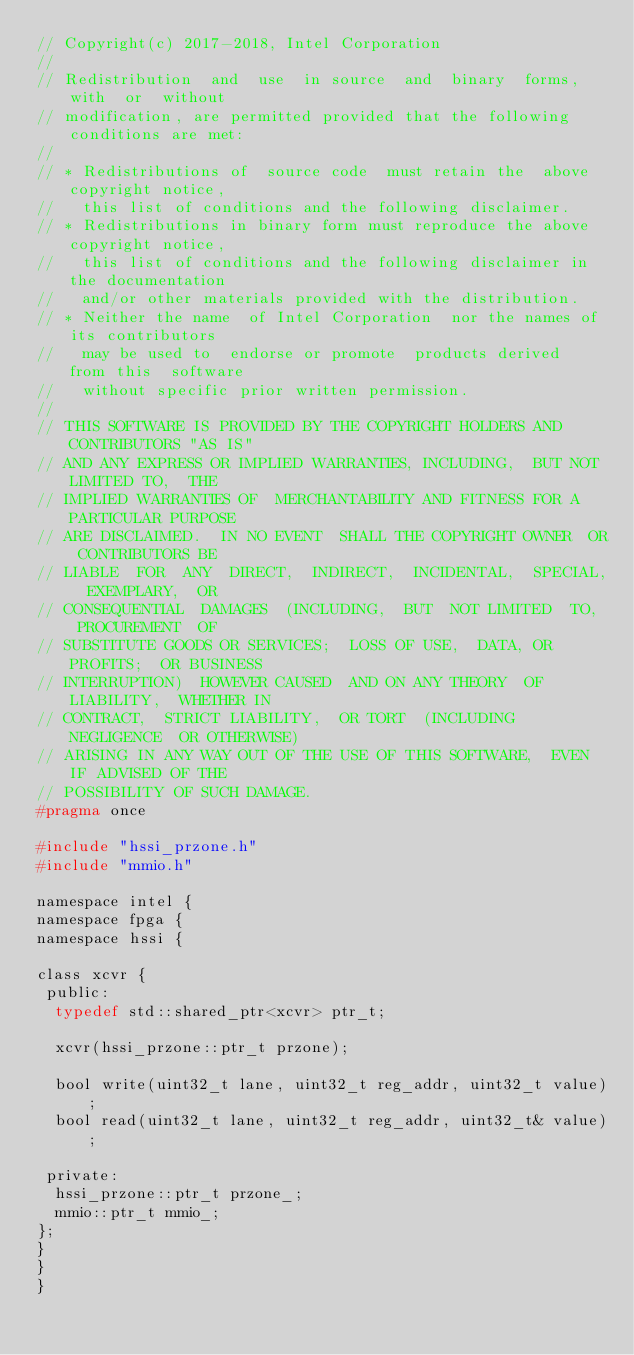Convert code to text. <code><loc_0><loc_0><loc_500><loc_500><_C_>// Copyright(c) 2017-2018, Intel Corporation
//
// Redistribution  and  use  in source  and  binary  forms,  with  or  without
// modification, are permitted provided that the following conditions are met:
//
// * Redistributions of  source code  must retain the  above copyright notice,
//   this list of conditions and the following disclaimer.
// * Redistributions in binary form must reproduce the above copyright notice,
//   this list of conditions and the following disclaimer in the documentation
//   and/or other materials provided with the distribution.
// * Neither the name  of Intel Corporation  nor the names of its contributors
//   may be used to  endorse or promote  products derived  from this  software
//   without specific prior written permission.
//
// THIS SOFTWARE IS PROVIDED BY THE COPYRIGHT HOLDERS AND CONTRIBUTORS "AS IS"
// AND ANY EXPRESS OR IMPLIED WARRANTIES, INCLUDING,  BUT NOT LIMITED TO,  THE
// IMPLIED WARRANTIES OF  MERCHANTABILITY AND FITNESS FOR A PARTICULAR PURPOSE
// ARE DISCLAIMED.  IN NO EVENT  SHALL THE COPYRIGHT OWNER  OR CONTRIBUTORS BE
// LIABLE  FOR  ANY  DIRECT,  INDIRECT,  INCIDENTAL,  SPECIAL,  EXEMPLARY,  OR
// CONSEQUENTIAL  DAMAGES  (INCLUDING,  BUT  NOT LIMITED  TO,  PROCUREMENT  OF
// SUBSTITUTE GOODS OR SERVICES;  LOSS OF USE,  DATA, OR PROFITS;  OR BUSINESS
// INTERRUPTION)  HOWEVER CAUSED  AND ON ANY THEORY  OF LIABILITY,  WHETHER IN
// CONTRACT,  STRICT LIABILITY,  OR TORT  (INCLUDING NEGLIGENCE  OR OTHERWISE)
// ARISING IN ANY WAY OUT OF THE USE OF THIS SOFTWARE,  EVEN IF ADVISED OF THE
// POSSIBILITY OF SUCH DAMAGE.
#pragma once

#include "hssi_przone.h"
#include "mmio.h"

namespace intel {
namespace fpga {
namespace hssi {

class xcvr {
 public:
  typedef std::shared_ptr<xcvr> ptr_t;

  xcvr(hssi_przone::ptr_t przone);

  bool write(uint32_t lane, uint32_t reg_addr, uint32_t value);
  bool read(uint32_t lane, uint32_t reg_addr, uint32_t& value);

 private:
  hssi_przone::ptr_t przone_;
  mmio::ptr_t mmio_;
};
}
}
}
</code> 